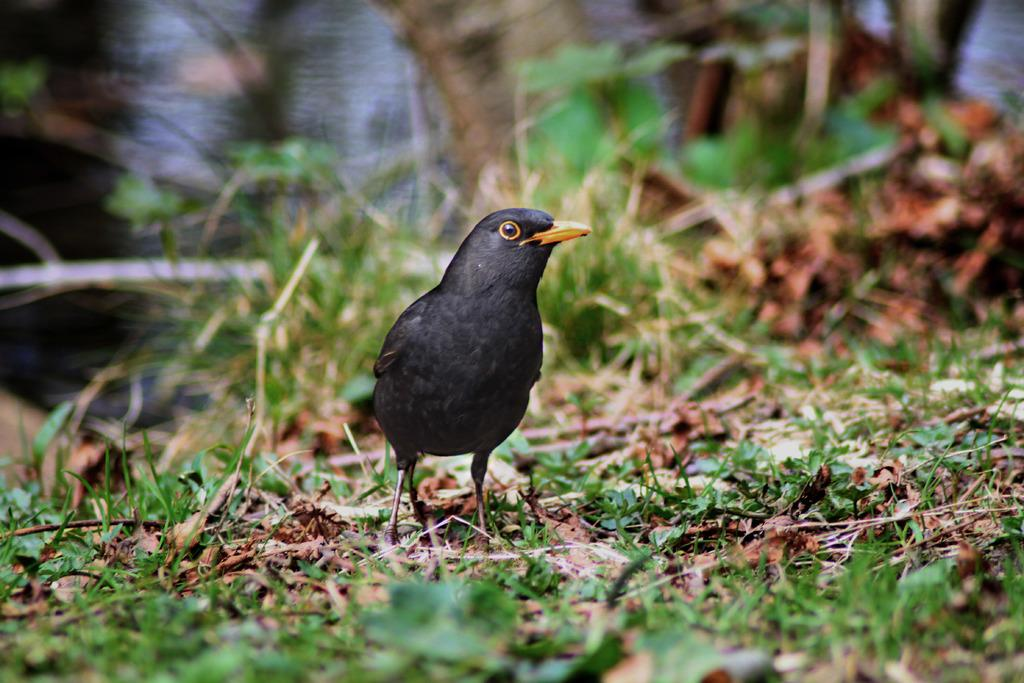What type of vegetation is present in the image? There is grass in the image. What kind of animal can be seen in the image? There is a black-colored bird in the image. How would you describe the quality of the image's background? The image is slightly blurry in the background. Where can the record be found in the image? There is no record present in the image. What type of wilderness is depicted in the image? The image does not depict any wilderness; it only shows grass and a black-colored bird. Is the zoo visible in the image? There is no zoo present in the image. 